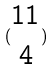<formula> <loc_0><loc_0><loc_500><loc_500>( \begin{matrix} 1 1 \\ 4 \end{matrix} )</formula> 